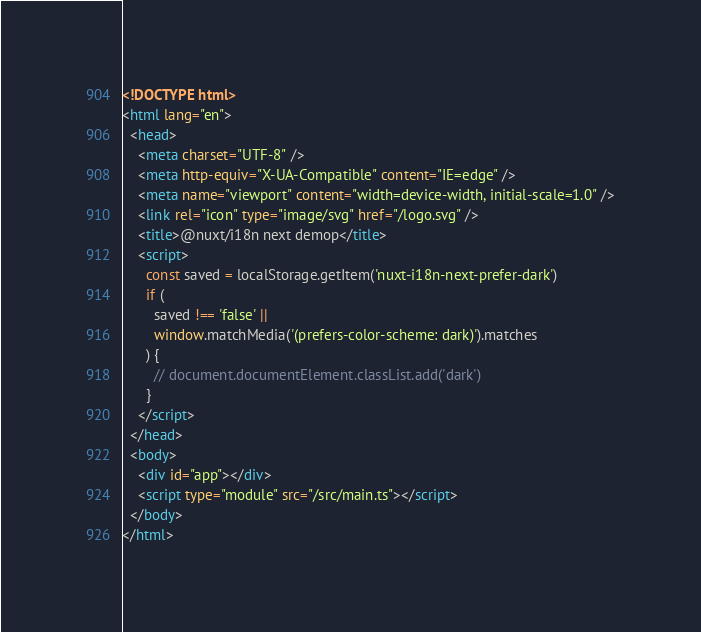Convert code to text. <code><loc_0><loc_0><loc_500><loc_500><_HTML_><!DOCTYPE html>
<html lang="en">
  <head>
    <meta charset="UTF-8" />
    <meta http-equiv="X-UA-Compatible" content="IE=edge" />
    <meta name="viewport" content="width=device-width, initial-scale=1.0" />
    <link rel="icon" type="image/svg" href="/logo.svg" />
    <title>@nuxt/i18n next demop</title>
    <script>
      const saved = localStorage.getItem('nuxt-i18n-next-prefer-dark')
      if (
        saved !== 'false' ||
        window.matchMedia('(prefers-color-scheme: dark)').matches
      ) {
        // document.documentElement.classList.add('dark')
      }
    </script>
  </head>
  <body>
    <div id="app"></div>
    <script type="module" src="/src/main.ts"></script>
  </body>
</html>
</code> 